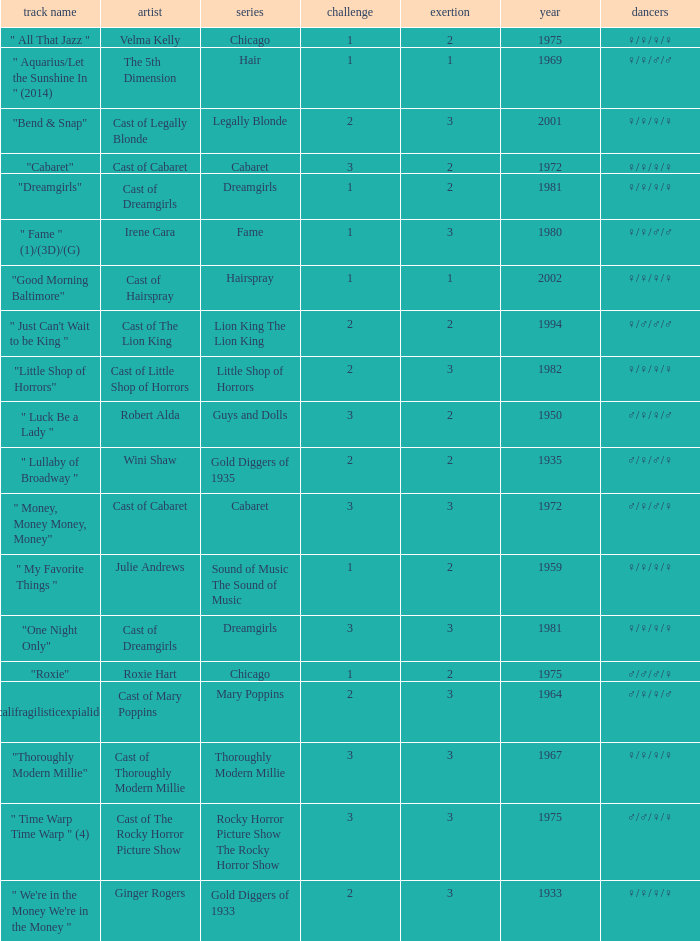What show featured the song "little shop of horrors"? Little Shop of Horrors. 